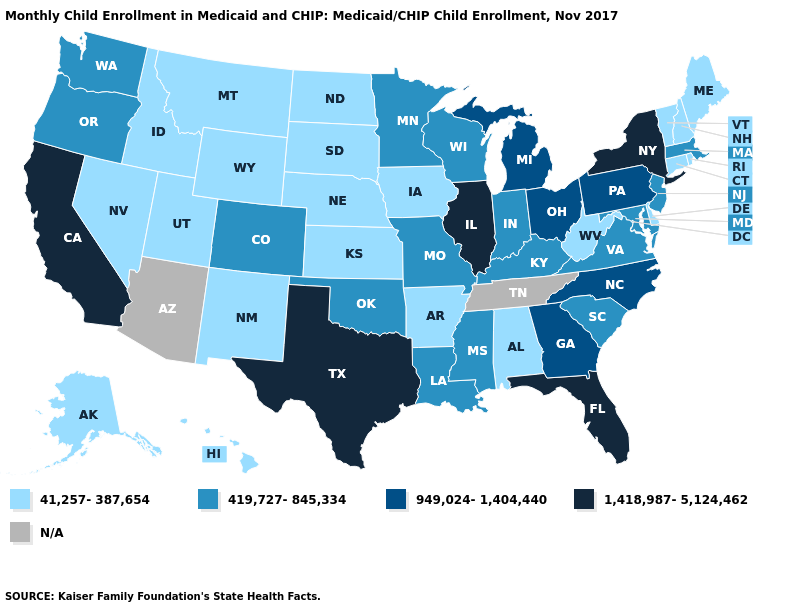What is the value of Idaho?
Concise answer only. 41,257-387,654. Does Massachusetts have the lowest value in the Northeast?
Write a very short answer. No. Among the states that border Georgia , which have the highest value?
Give a very brief answer. Florida. Among the states that border Rhode Island , which have the lowest value?
Keep it brief. Connecticut. Name the states that have a value in the range 41,257-387,654?
Give a very brief answer. Alabama, Alaska, Arkansas, Connecticut, Delaware, Hawaii, Idaho, Iowa, Kansas, Maine, Montana, Nebraska, Nevada, New Hampshire, New Mexico, North Dakota, Rhode Island, South Dakota, Utah, Vermont, West Virginia, Wyoming. What is the value of South Dakota?
Give a very brief answer. 41,257-387,654. What is the lowest value in the USA?
Quick response, please. 41,257-387,654. Name the states that have a value in the range N/A?
Keep it brief. Arizona, Tennessee. Name the states that have a value in the range 41,257-387,654?
Quick response, please. Alabama, Alaska, Arkansas, Connecticut, Delaware, Hawaii, Idaho, Iowa, Kansas, Maine, Montana, Nebraska, Nevada, New Hampshire, New Mexico, North Dakota, Rhode Island, South Dakota, Utah, Vermont, West Virginia, Wyoming. Which states have the highest value in the USA?
Quick response, please. California, Florida, Illinois, New York, Texas. What is the value of New Mexico?
Be succinct. 41,257-387,654. Which states have the lowest value in the West?
Keep it brief. Alaska, Hawaii, Idaho, Montana, Nevada, New Mexico, Utah, Wyoming. Does the first symbol in the legend represent the smallest category?
Write a very short answer. Yes. 